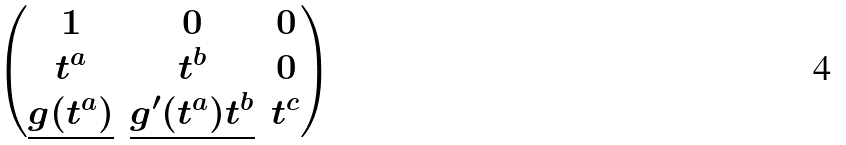Convert formula to latex. <formula><loc_0><loc_0><loc_500><loc_500>\begin{pmatrix} 1 & 0 & 0 \\ t ^ { a } & t ^ { b } & 0 \\ \underline { g ( t ^ { a } ) } & \underline { g ^ { \prime } ( t ^ { a } ) t ^ { b } } & t ^ { c } \end{pmatrix}</formula> 